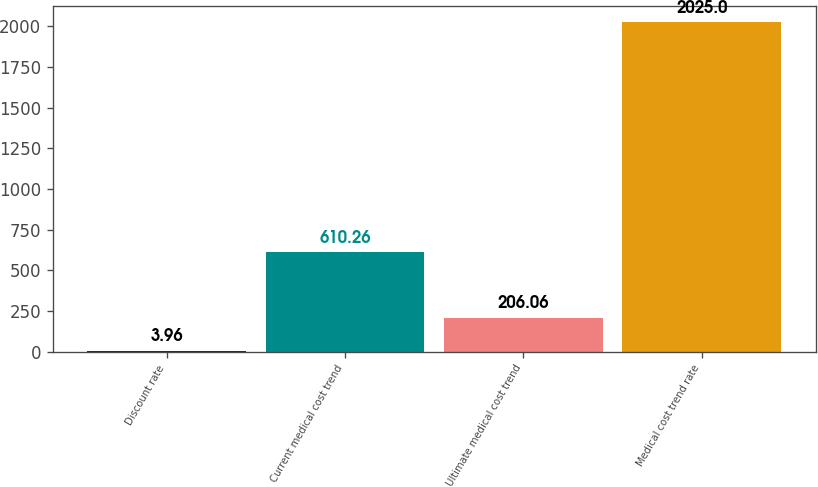Convert chart to OTSL. <chart><loc_0><loc_0><loc_500><loc_500><bar_chart><fcel>Discount rate<fcel>Current medical cost trend<fcel>Ultimate medical cost trend<fcel>Medical cost trend rate<nl><fcel>3.96<fcel>610.26<fcel>206.06<fcel>2025<nl></chart> 